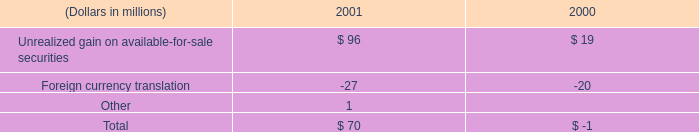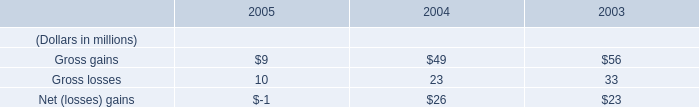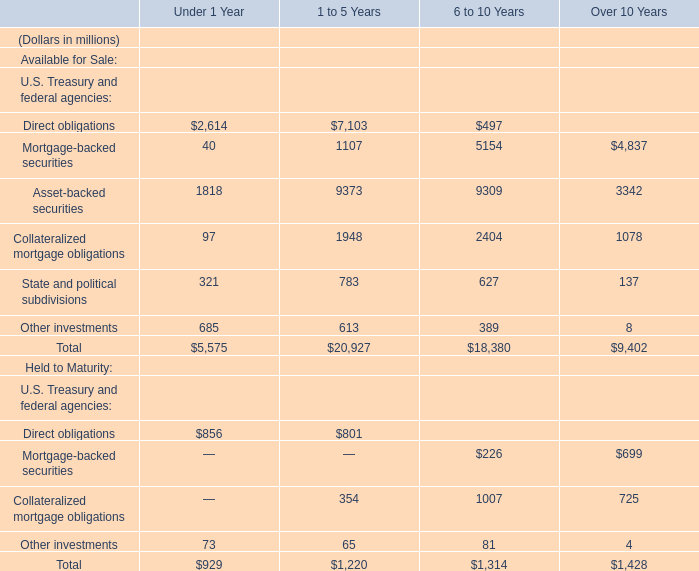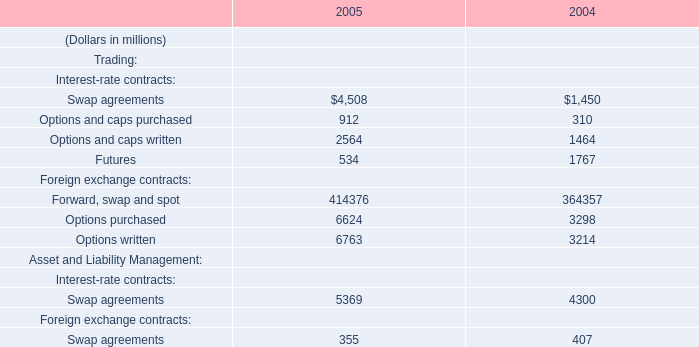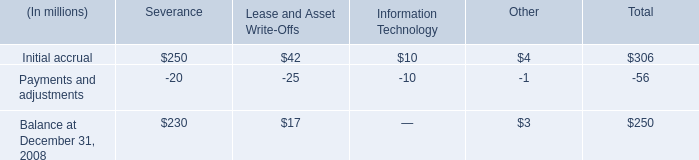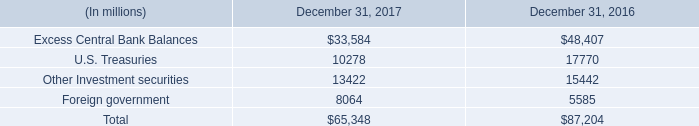what percent of severence was paid off in 2008? 
Computations: (20 / 250)
Answer: 0.08. 